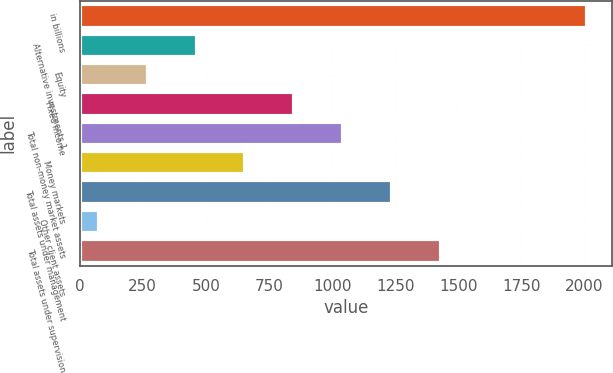<chart> <loc_0><loc_0><loc_500><loc_500><bar_chart><fcel>in billions<fcel>Alternative investments 1<fcel>Equity<fcel>Fixed income<fcel>Total non-money market assets<fcel>Money markets<fcel>Total assets under management<fcel>Other client assets<fcel>Total assets under supervision<nl><fcel>2010<fcel>463.6<fcel>270.3<fcel>850.2<fcel>1043.5<fcel>656.9<fcel>1236.8<fcel>77<fcel>1430.1<nl></chart> 